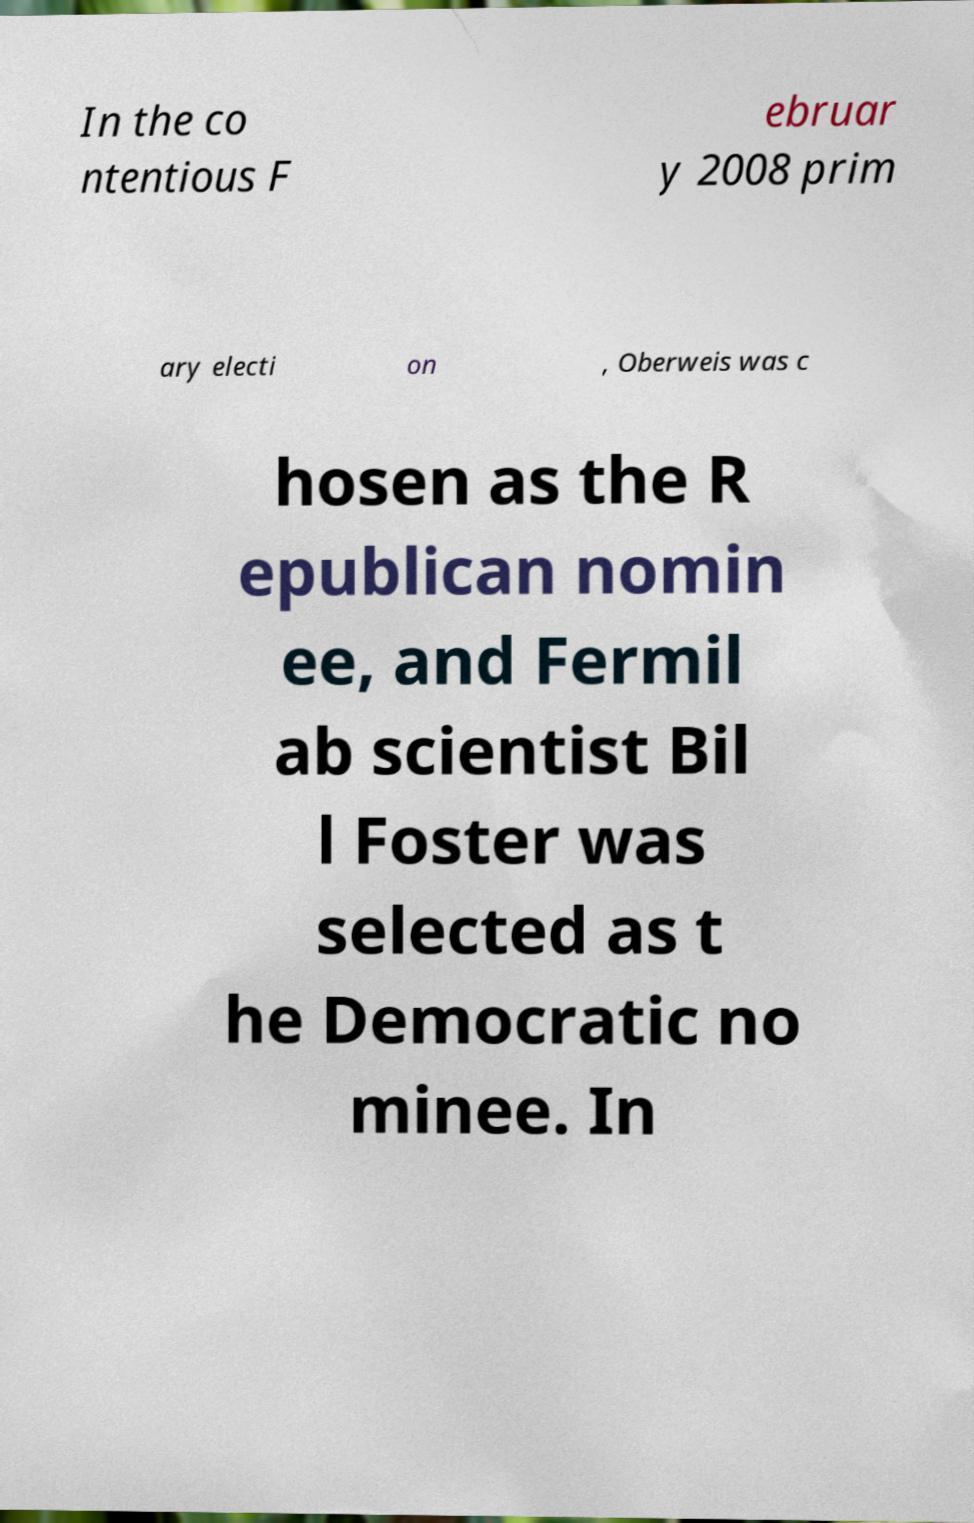I need the written content from this picture converted into text. Can you do that? In the co ntentious F ebruar y 2008 prim ary electi on , Oberweis was c hosen as the R epublican nomin ee, and Fermil ab scientist Bil l Foster was selected as t he Democratic no minee. In 